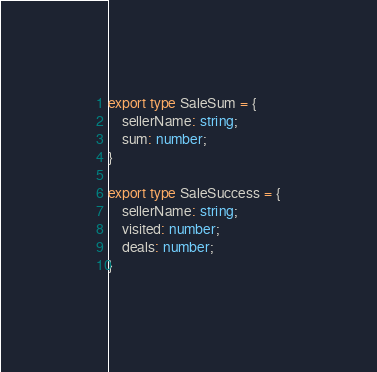Convert code to text. <code><loc_0><loc_0><loc_500><loc_500><_TypeScript_>
export type SaleSum = {
    sellerName: string;
    sum: number;
}

export type SaleSuccess = {
    sellerName: string;
    visited: number;
    deals: number;
}

</code> 